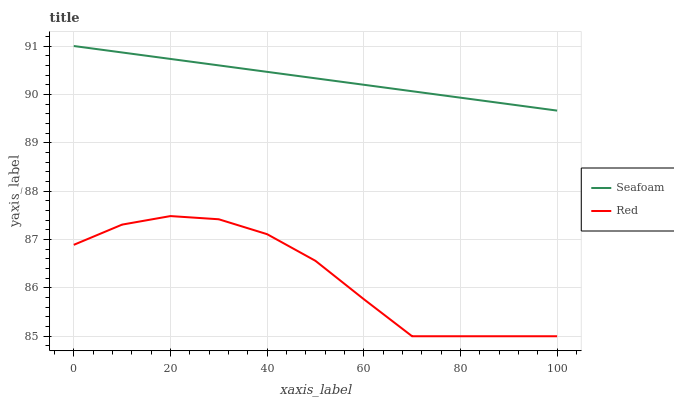Does Red have the minimum area under the curve?
Answer yes or no. Yes. Does Seafoam have the maximum area under the curve?
Answer yes or no. Yes. Does Red have the maximum area under the curve?
Answer yes or no. No. Is Seafoam the smoothest?
Answer yes or no. Yes. Is Red the roughest?
Answer yes or no. Yes. Is Red the smoothest?
Answer yes or no. No. Does Red have the lowest value?
Answer yes or no. Yes. Does Seafoam have the highest value?
Answer yes or no. Yes. Does Red have the highest value?
Answer yes or no. No. Is Red less than Seafoam?
Answer yes or no. Yes. Is Seafoam greater than Red?
Answer yes or no. Yes. Does Red intersect Seafoam?
Answer yes or no. No. 